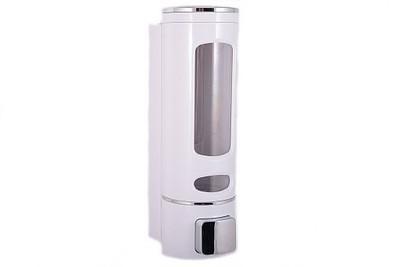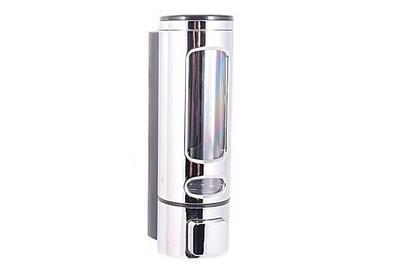The first image is the image on the left, the second image is the image on the right. Considering the images on both sides, is "Exactly three wall mounted bathroom dispensers are shown, with two matching dispensers in one image and different third dispenser in the other image." valid? Answer yes or no. No. The first image is the image on the left, the second image is the image on the right. Assess this claim about the two images: "An image shows side-by-side dispensers with black dispenser 'buttons'.". Correct or not? Answer yes or no. No. 